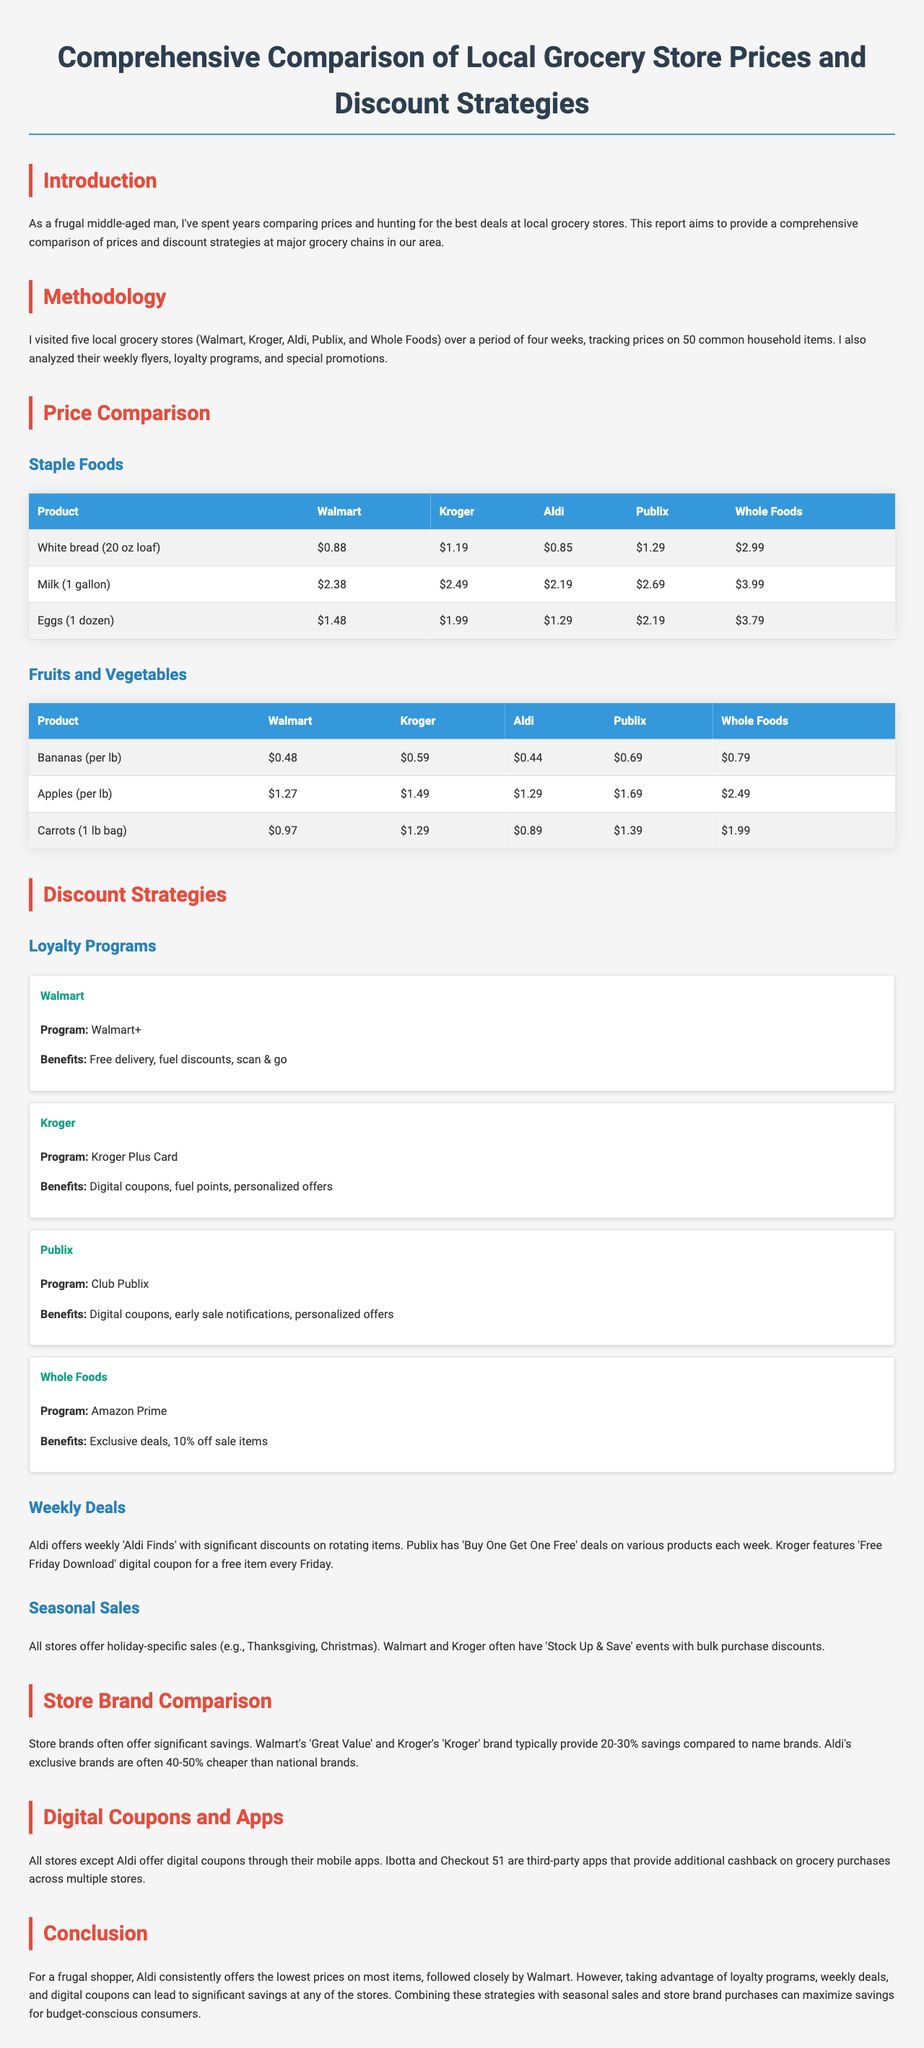what is the main purpose of the report? The report aims to provide a comprehensive comparison of prices and discount strategies at major grocery chains in our area.
Answer: price comparison and discount strategies how many grocery stores were visited for the analysis? The analysis involved visiting five local grocery stores.
Answer: five which store offers the lowest price for a gallon of milk? The prices for a gallon of milk were compared, and Aldi offers the lowest price at $2.19.
Answer: Aldi what is the name of Walmart's loyalty program? Walmart's loyalty program is called Walmart+.
Answer: Walmart+ which grocery store is known for its 'Buy One Get One Free' deals? Publix is known for its 'Buy One Get One Free' deals on various products each week.
Answer: Publix how much cheaper are Aldi's exclusive brands compared to national brands? Aldi's exclusive brands are often 40-50% cheaper than national brands.
Answer: 40-50% which store provides digital coupons through their mobile app? All stores except Aldi offer digital coupons through their mobile apps.
Answer: all except Aldi what is stated as the conclusion for frugal shoppers? For a frugal shopper, Aldi consistently offers the lowest prices on most items.
Answer: Aldi what percentage savings do Walmart's 'Great Value' brand typically provide? Walmart's 'Great Value' brand typically provide 20-30% savings compared to name brands.
Answer: 20-30% 